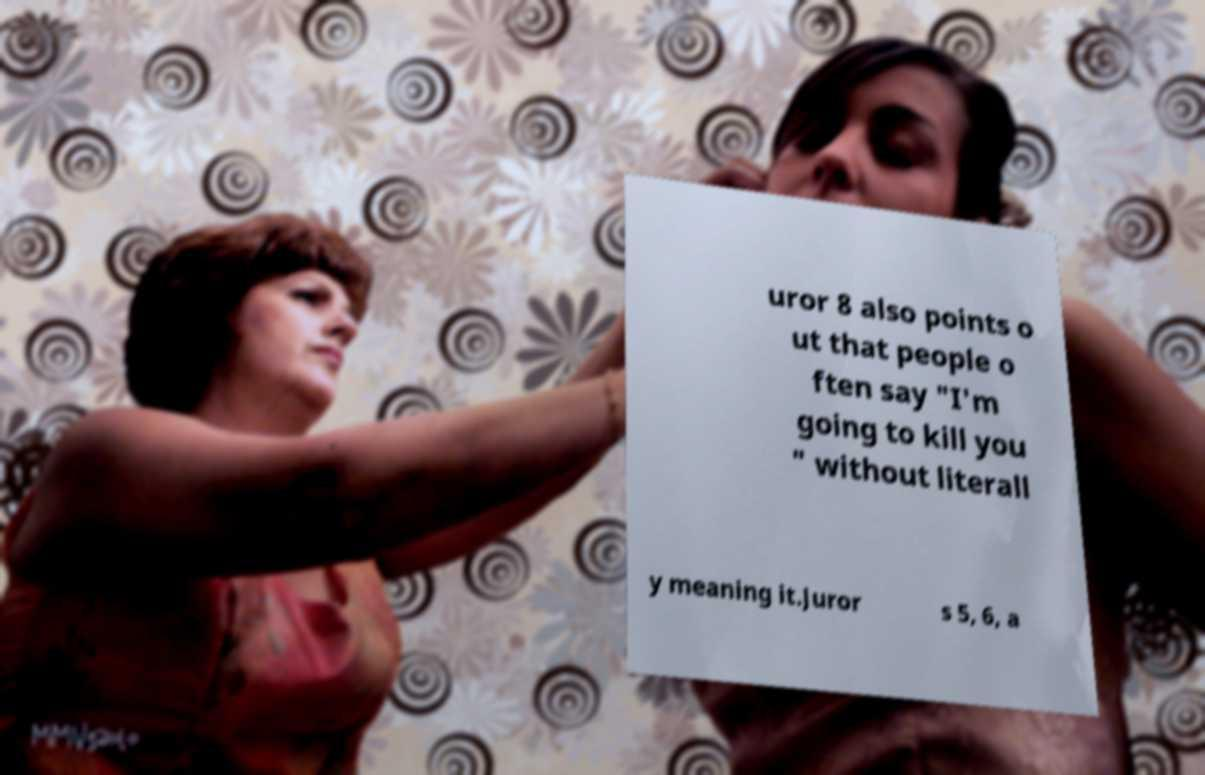Could you assist in decoding the text presented in this image and type it out clearly? uror 8 also points o ut that people o ften say "I'm going to kill you " without literall y meaning it.Juror s 5, 6, a 